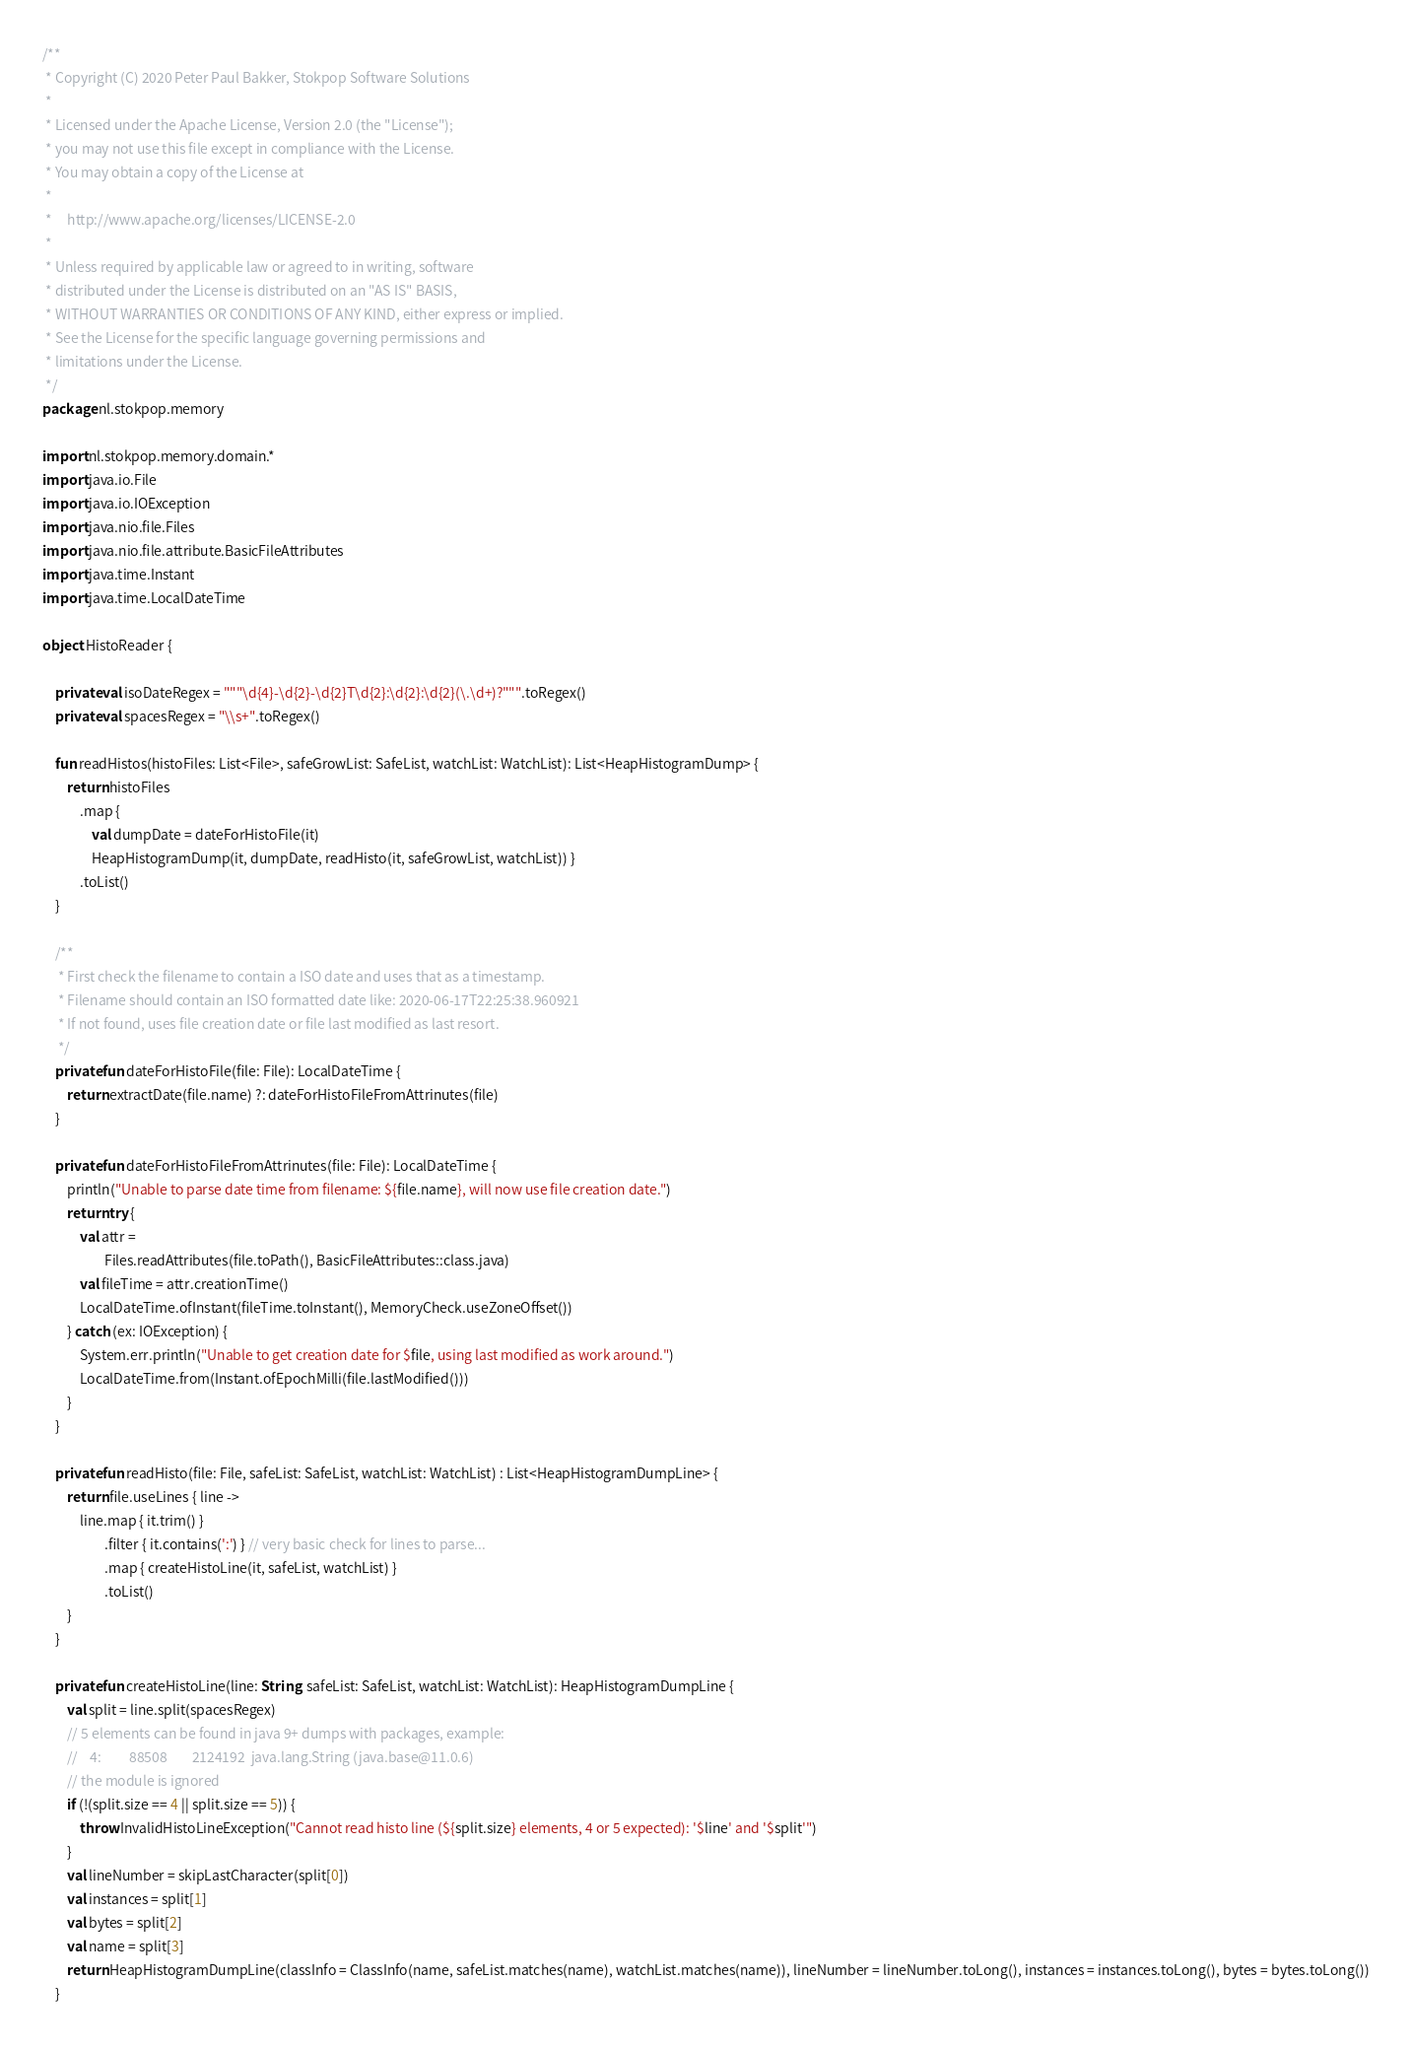Convert code to text. <code><loc_0><loc_0><loc_500><loc_500><_Kotlin_>/**
 * Copyright (C) 2020 Peter Paul Bakker, Stokpop Software Solutions
 *
 * Licensed under the Apache License, Version 2.0 (the "License");
 * you may not use this file except in compliance with the License.
 * You may obtain a copy of the License at
 *
 *     http://www.apache.org/licenses/LICENSE-2.0
 *
 * Unless required by applicable law or agreed to in writing, software
 * distributed under the License is distributed on an "AS IS" BASIS,
 * WITHOUT WARRANTIES OR CONDITIONS OF ANY KIND, either express or implied.
 * See the License for the specific language governing permissions and
 * limitations under the License.
 */
package nl.stokpop.memory

import nl.stokpop.memory.domain.*
import java.io.File
import java.io.IOException
import java.nio.file.Files
import java.nio.file.attribute.BasicFileAttributes
import java.time.Instant
import java.time.LocalDateTime

object HistoReader {

    private val isoDateRegex = """\d{4}-\d{2}-\d{2}T\d{2}:\d{2}:\d{2}(\.\d+)?""".toRegex()
    private val spacesRegex = "\\s+".toRegex()

    fun readHistos(histoFiles: List<File>, safeGrowList: SafeList, watchList: WatchList): List<HeapHistogramDump> {
        return histoFiles
            .map {
                val dumpDate = dateForHistoFile(it)
                HeapHistogramDump(it, dumpDate, readHisto(it, safeGrowList, watchList)) }
            .toList()
    }

    /**
     * First check the filename to contain a ISO date and uses that as a timestamp.
     * Filename should contain an ISO formatted date like: 2020-06-17T22:25:38.960921
     * If not found, uses file creation date or file last modified as last resort.
     */
    private fun dateForHistoFile(file: File): LocalDateTime {
        return extractDate(file.name) ?: dateForHistoFileFromAttrinutes(file)
    }

    private fun dateForHistoFileFromAttrinutes(file: File): LocalDateTime {
        println("Unable to parse date time from filename: ${file.name}, will now use file creation date.")
        return try {
            val attr =
                    Files.readAttributes(file.toPath(), BasicFileAttributes::class.java)
            val fileTime = attr.creationTime()
            LocalDateTime.ofInstant(fileTime.toInstant(), MemoryCheck.useZoneOffset())
        } catch (ex: IOException) {
            System.err.println("Unable to get creation date for $file, using last modified as work around.")
            LocalDateTime.from(Instant.ofEpochMilli(file.lastModified()))
        }
    }

    private fun readHisto(file: File, safeList: SafeList, watchList: WatchList) : List<HeapHistogramDumpLine> {
        return file.useLines { line ->
            line.map { it.trim() }
                    .filter { it.contains(':') } // very basic check for lines to parse...
                    .map { createHistoLine(it, safeList, watchList) }
                    .toList()
        }
    }

    private fun createHistoLine(line: String, safeList: SafeList, watchList: WatchList): HeapHistogramDumpLine {
        val split = line.split(spacesRegex)
        // 5 elements can be found in java 9+ dumps with packages, example:
        //    4:         88508        2124192  java.lang.String (java.base@11.0.6)
        // the module is ignored
        if (!(split.size == 4 || split.size == 5)) {
            throw InvalidHistoLineException("Cannot read histo line (${split.size} elements, 4 or 5 expected): '$line' and '$split'")
        }
        val lineNumber = skipLastCharacter(split[0])
        val instances = split[1]
        val bytes = split[2]
        val name = split[3]
        return HeapHistogramDumpLine(classInfo = ClassInfo(name, safeList.matches(name), watchList.matches(name)), lineNumber = lineNumber.toLong(), instances = instances.toLong(), bytes = bytes.toLong())
    }
</code> 